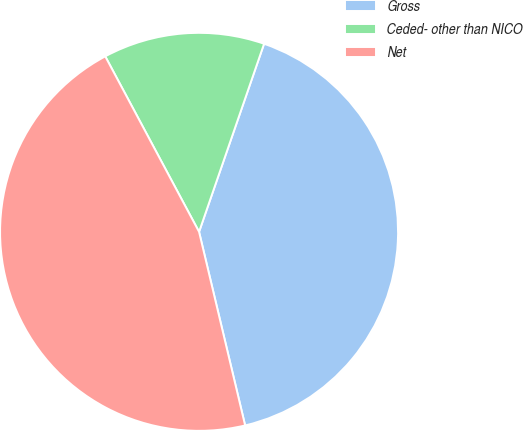<chart> <loc_0><loc_0><loc_500><loc_500><pie_chart><fcel>Gross<fcel>Ceded- other than NICO<fcel>Net<nl><fcel>40.98%<fcel>13.11%<fcel>45.9%<nl></chart> 